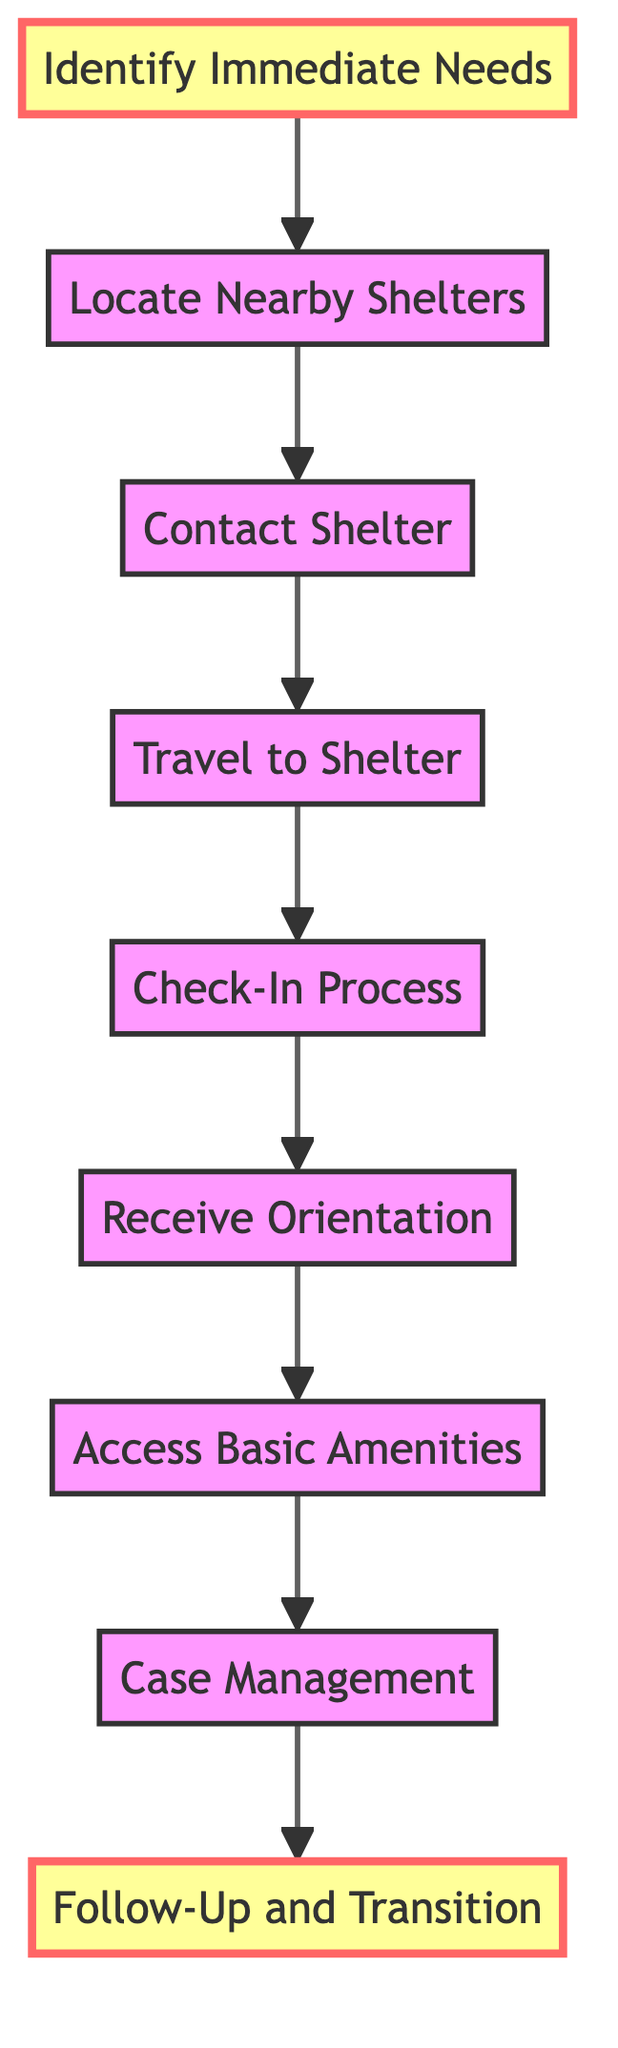What is the first step in the flow chart? The diagram indicates that the first step is "Identify Immediate Needs," which is the initial action to assess what assistance may be required.
Answer: Identify Immediate Needs How many total steps are there in the flow chart? By counting the individual steps listed in the flow chart, we can see there are nine distinct steps in total.
Answer: 9 What step comes immediately after "Check-In Process"? The diagram shows that after "Check-In Process," the next step is "Receive Orientation," indicating the sequence of actions.
Answer: Receive Orientation What are the last two steps in the flow chart? The final steps in the flow chart are "Case Management" followed by "Follow-Up and Transition," showcasing the progression towards long-term support.
Answer: Case Management, Follow-Up and Transition Which step requires contacting the shelter? The flow chart indicates that the step titled "Contact Shelter" is specifically where individuals are required to reach out to the shelter for information.
Answer: Contact Shelter What is required during the "Check-In Process"? According to the description in the flow chart, the "Check-In Process" requires registering with shelter staff and potentially providing necessary documentation like identification.
Answer: Register and provide documentation What is the relationship between "Travel to Shelter" and "Access Basic Amenities"? The flow chart indicates a sequential relationship, where "Travel to Shelter" must be completed before accessing basic amenities provided by the shelter, indicating a step-by-step process in navigating shelter services.
Answer: Sequential relationship In which step do individuals meet with a caseworker? The diagram specifies that individuals will meet with a caseworker during the "Case Management" step, which focuses on discussing long-term options and support services.
Answer: Case Management What resource can be used to find nearby shelters? The flow chart suggests using resources like the National Coalition for the Homeless website or a local 211 hotline to locate nearby shelter options.
Answer: National Coalition for the Homeless website or local 211 hotline 